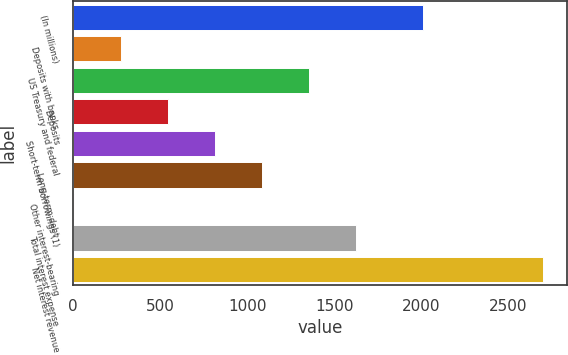<chart> <loc_0><loc_0><loc_500><loc_500><bar_chart><fcel>(In millions)<fcel>Deposits with banks<fcel>US Treasury and federal<fcel>Deposits<fcel>Short-term borrowings (1)<fcel>Long-term debt<fcel>Other interest-bearing<fcel>Total interest expense<fcel>Net interest revenue<nl><fcel>2010<fcel>276.2<fcel>1353<fcel>545.4<fcel>814.6<fcel>1083.8<fcel>7<fcel>1622.2<fcel>2699<nl></chart> 